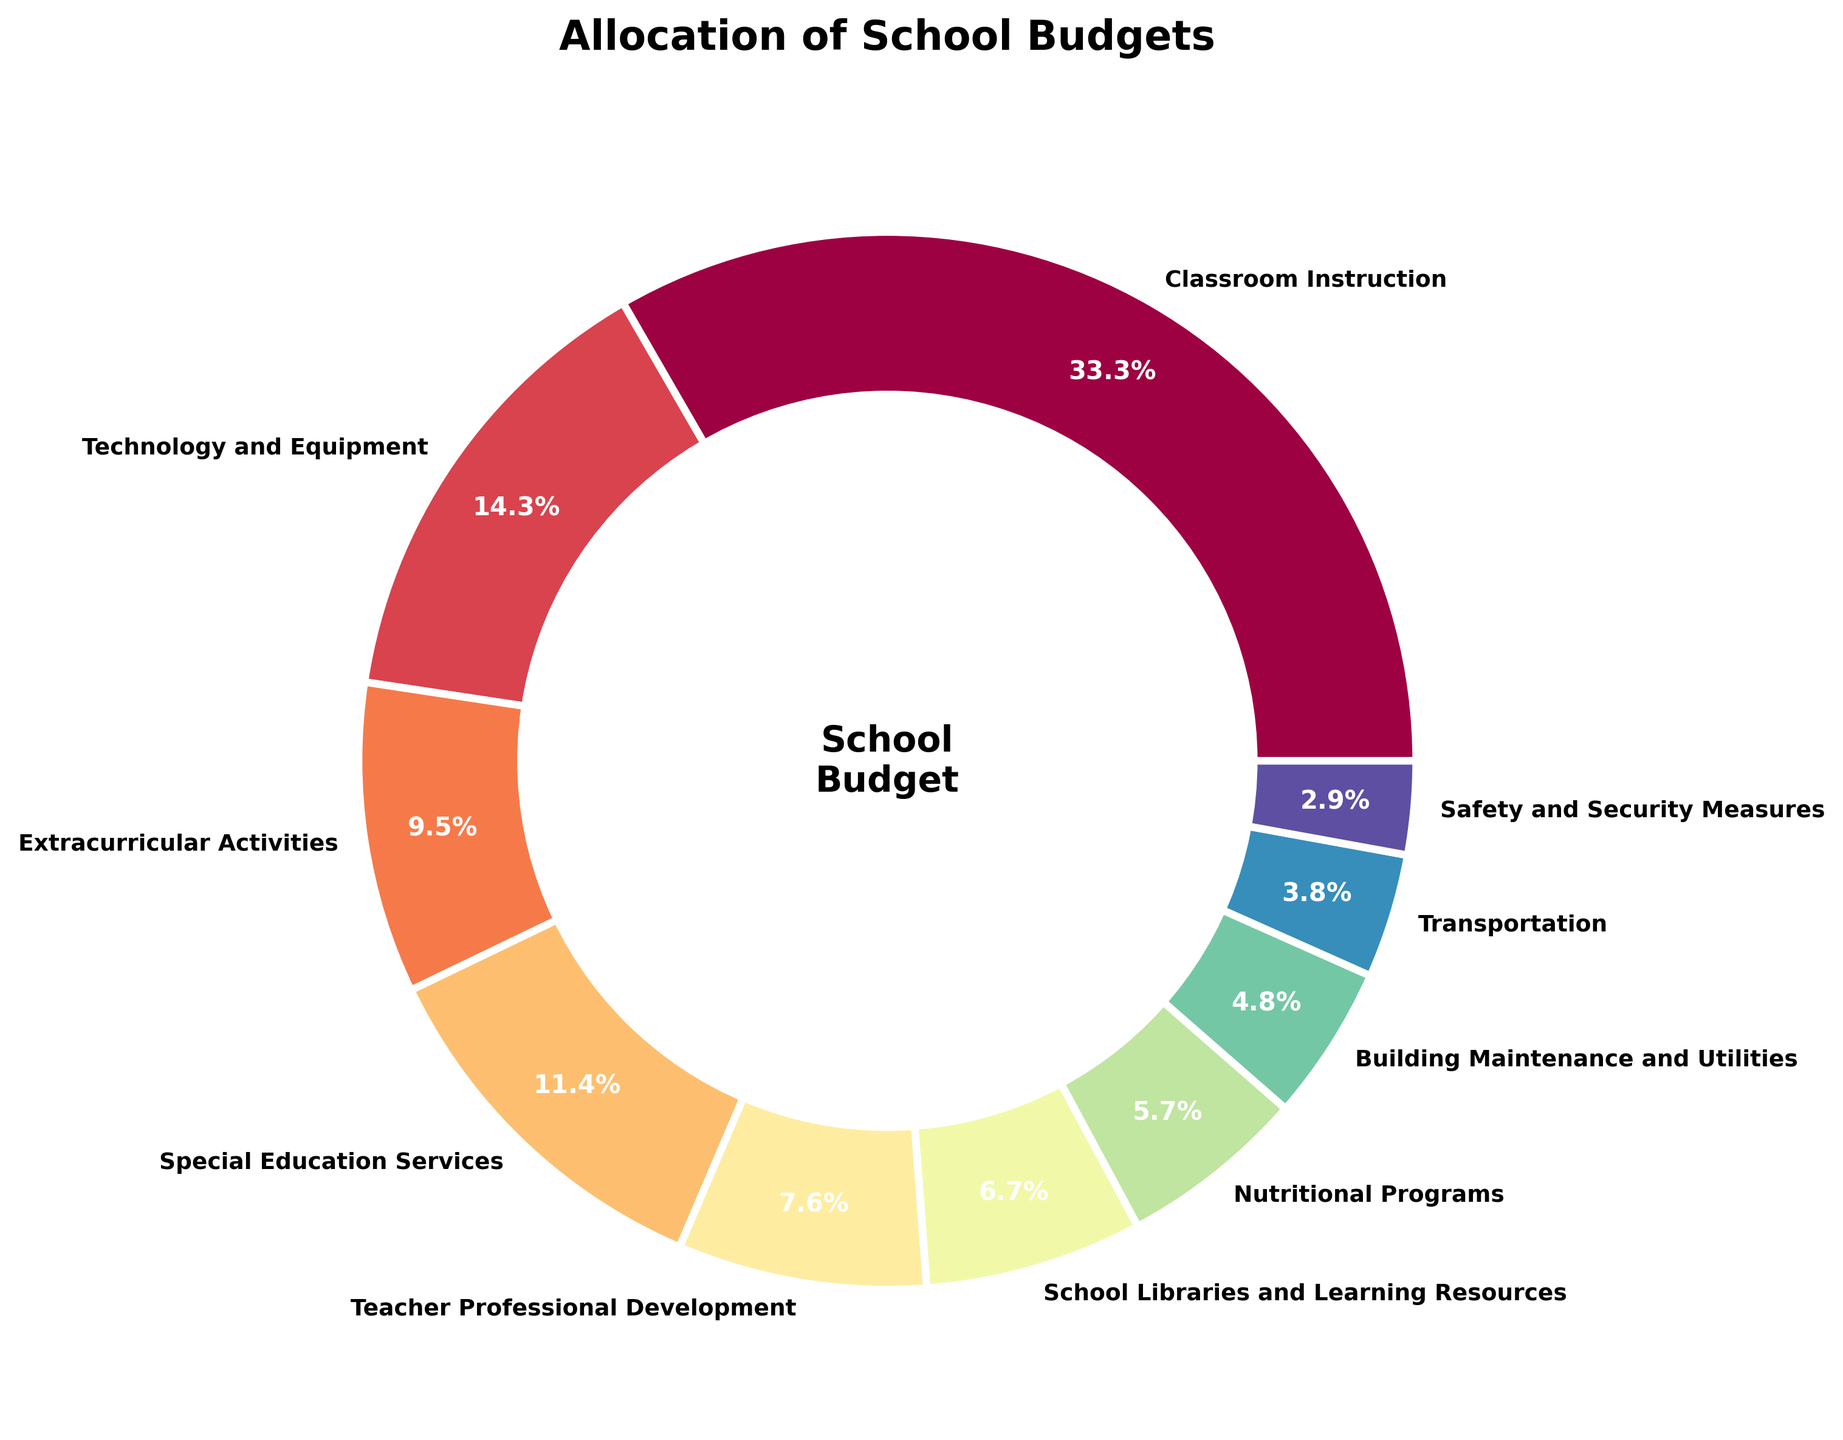What percentage of the school budget is allocated to classrooms and teacher professional development combined? First, identify the percentages for Classroom Instruction (35%) and Teacher Professional Development (8%). Then add these values together: 35% + 8% = 43%.
Answer: 43% Which category in the pie chart receives the least amount of funding? Look at all the categories and their corresponding percentages. The category with the lowest percentage is Safety and Security Measures at 3%.
Answer: Safety and Security Measures How much more budget percentage is allocated to technology and equipment compared to school libraries and learning resources? Identify the percentages for Technology and Equipment (15%) and School Libraries and Learning Resources (7%). The difference is calculated as 15% - 7% = 8%.
Answer: 8% Is the allocation for transportation greater than, less than, or equal to the allocation for nutritional programs? Identify the percentages for Transportation (4%) and Nutritional Programs (6%). Compare the two values: 4% is less than 6%.
Answer: Less than Which categories combined make up more than half of the school budget? First, identify the largest categories and their percentages: Classroom Instruction (35%), Technology and Equipment (15%), and Special Education Services (12%). Add them together: 35% + 15% + 12% = 62%, which is more than half.
Answer: Classroom Instruction, Technology and Equipment, Special Education Services What is the total percentage allocated to extracurricular activities, school libraries, and building maintenance combined? Identify the percentages for Extracurricular Activities (10%), School Libraries and Learning Resources (7%), and Building Maintenance and Utilities (5%). Add these values: 10% + 7% + 5% = 22%.
Answer: 22% Which category receives an allocation closest to the average budget percentage across all categories? Calculate the average by dividing the total percentage (sum of all categories is 100%) by the number of categories (10). The average percentage is 100% / 10 = 10%. The closest category to this average is Extracurricular Activities at 10%.
Answer: Extracurricular Activities How much more budget is allocated to special education services than to safety and security measures? Identify the percentages for Special Education Services (12%) and Safety and Security Measures (3%). The difference is 12% - 3% = 9%.
Answer: 9% If the school decided to increase the budget for transportation by 2%, what would the new percentage for transportation be? Current allocation for Transportation is 4%. Adding 2% gives 4% + 2% = 6%.
Answer: 6% What is the combined budget percentage for programs directly related to student activities (extracurricular activities and nutritional programs)? Identify the percentages for Extracurricular Activities (10%) and Nutritional Programs (6%). Combine them: 10% + 6% = 16%.
Answer: 16% 